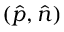Convert formula to latex. <formula><loc_0><loc_0><loc_500><loc_500>( \hat { p } , \hat { n } )</formula> 